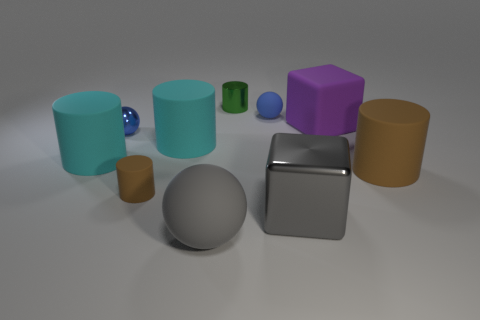Is the material of the block behind the gray block the same as the big brown object?
Your answer should be compact. Yes. Is there a big object that has the same color as the tiny matte cylinder?
Give a very brief answer. Yes. Does the small metallic object behind the tiny blue matte ball have the same shape as the blue thing that is to the left of the small brown rubber cylinder?
Keep it short and to the point. No. Are there any small red balls made of the same material as the big brown thing?
Your response must be concise. No. What number of yellow objects are either small metallic spheres or tiny matte cylinders?
Provide a short and direct response. 0. There is a rubber object that is right of the small metal cylinder and on the left side of the large purple rubber block; what size is it?
Provide a succinct answer. Small. Are there more matte cubes that are behind the big brown rubber object than small green rubber objects?
Provide a succinct answer. Yes. What number of cylinders are either blue objects or small brown rubber objects?
Keep it short and to the point. 1. What shape is the big object that is both in front of the tiny matte cylinder and left of the big gray shiny block?
Keep it short and to the point. Sphere. Are there the same number of large gray rubber spheres that are behind the blue matte ball and small blue matte objects that are on the left side of the green cylinder?
Provide a short and direct response. Yes. 